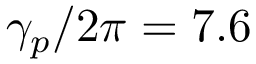<formula> <loc_0><loc_0><loc_500><loc_500>\gamma _ { p } / 2 \pi = 7 . 6</formula> 